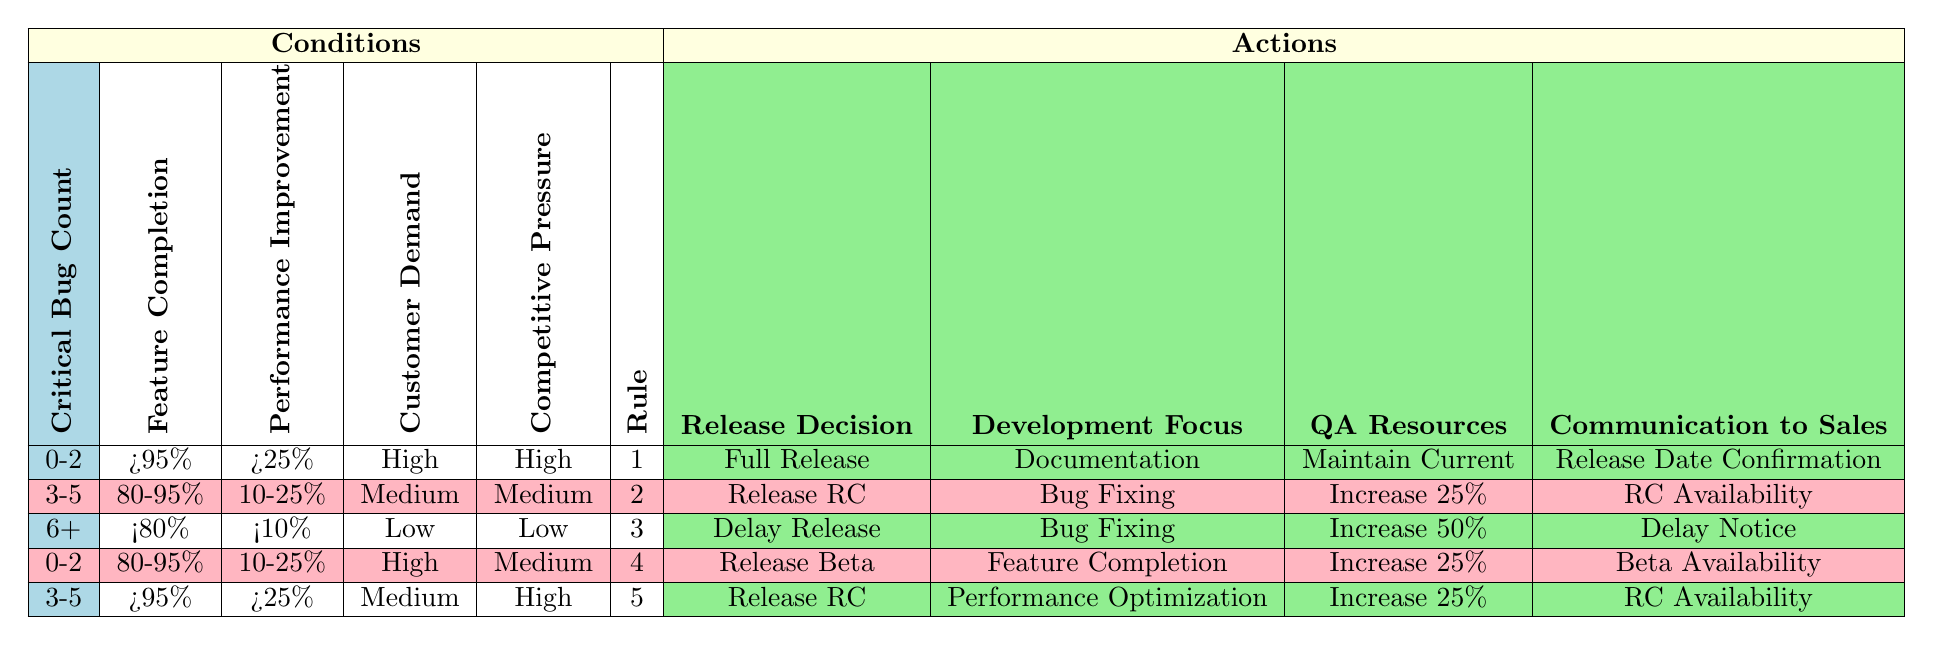What is the release decision for a scenario with 0-2 critical bugs, feature completion greater than 95%, and high customer demand? In the table, the row that matches these conditions has a release decision of "Full Release".
Answer: Full Release How many different actions can be taken when there are 3-5 critical bugs, feature completion between 80% and 95%, and medium customer demand? For the conditions mentioned, there is one corresponding row in the table. The actions associated with it are "Release RC", "Bug Fixing", "Increase 25%", and "RC Availability". This indicates there are four actions available.
Answer: 4 Is it true that a delay in release is warranted when critical bugs exceed 6, features are completed under 80%, and customer demand is low? Yes, the table shows that for critical bugs of 6+, feature completion of <80%, and both customer and competitive demand being low, the release decision is "Delay Release".
Answer: Yes What is the development focus if we release a beta for a scenario with 0-2 critical bugs, feature completion between 80% and 95%, high customer demand, and medium competitive pressure? Looking at the table, the row that corresponds to these conditions indicates that the development focus should be on "Feature Completion".
Answer: Feature Completion If the critical bug count is 3-5 and performance improvement is greater than 25%, is the communication to sales regarding beta availability? No, based on the table, the conditions of 3-5 critical bugs and performance improvement of >25% correspond to a release candidate decision (RC). The communication type in this row is "RC Availability", not beta availability.
Answer: No In how many cases do we have a release decision of "Release RC"? There are two rows in the table that indicate a "Release RC" decision under the specified conditions.
Answer: 2 What are the QA resources recommended when the critical bug count is 6 or greater, feature completion is less than 80%, and customer demand is low? The relevant row shows that the recommendation for QA resources in this scenario is "Increase 50%".
Answer: Increase 50% What actions should be taken when the critical bug count is between 3 to 5 and feature completion is over 95% with a medium competitive pressure? Only one row matches this scenario, which suggests the actions to take are "Release RC", "Performance Optimization", and "Increase 25%", along with the communication to sales being "RC Availability".
Answer: Release RC, Performance Optimization, Increase 25%, RC Availability What is the communication action when critical bugs are between 0-2, features are at 80-95% completion, with high customer demand and medium competitive pressure? The corresponding actions for those conditions indicate "Beta Availability" for communication to sales.
Answer: Beta Availability 